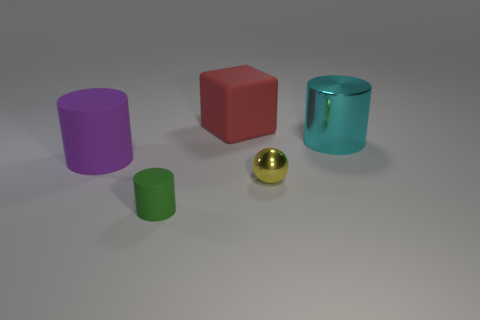Do the big cyan object and the yellow thing have the same shape?
Offer a terse response. No. Does the shiny thing on the left side of the large cyan metallic object have the same size as the object that is on the left side of the green rubber object?
Offer a terse response. No. There is a matte object behind the large shiny object; what size is it?
Ensure brevity in your answer.  Large. Is the number of purple matte objects behind the metal ball greater than the number of big yellow objects?
Keep it short and to the point. Yes. What number of things are small objects that are to the left of the red block or big matte objects?
Provide a short and direct response. 3. What number of small yellow things are made of the same material as the large purple cylinder?
Offer a terse response. 0. Is there another matte object that has the same shape as the purple rubber object?
Offer a terse response. Yes. There is a yellow shiny object that is the same size as the green rubber cylinder; what shape is it?
Your answer should be very brief. Sphere. There is a big cylinder that is left of the red matte object; how many large purple matte cylinders are behind it?
Provide a succinct answer. 0. What is the size of the cylinder that is both behind the tiny yellow metal ball and to the right of the purple rubber cylinder?
Ensure brevity in your answer.  Large. 